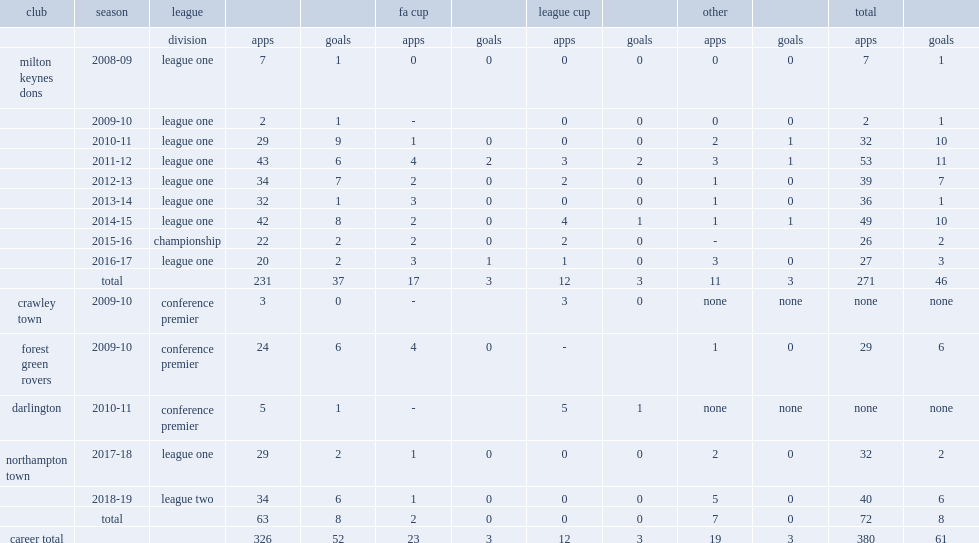How many goals did powell made with 42 league appearances in 2014-2015, for the milton keynes dons club? 8.0. 